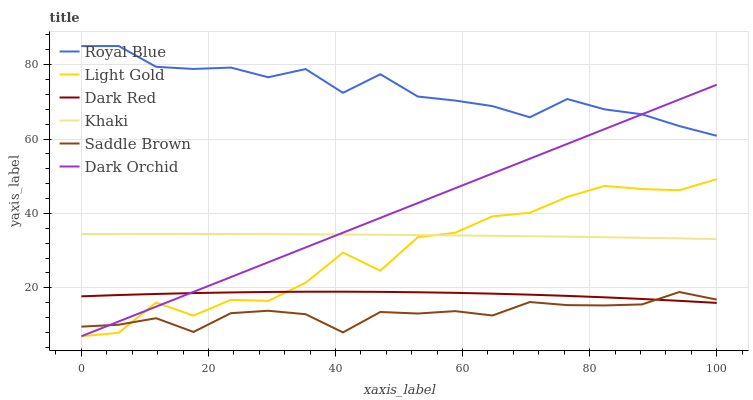Does Saddle Brown have the minimum area under the curve?
Answer yes or no. Yes. Does Royal Blue have the maximum area under the curve?
Answer yes or no. Yes. Does Dark Red have the minimum area under the curve?
Answer yes or no. No. Does Dark Red have the maximum area under the curve?
Answer yes or no. No. Is Dark Orchid the smoothest?
Answer yes or no. Yes. Is Light Gold the roughest?
Answer yes or no. Yes. Is Dark Red the smoothest?
Answer yes or no. No. Is Dark Red the roughest?
Answer yes or no. No. Does Dark Orchid have the lowest value?
Answer yes or no. Yes. Does Dark Red have the lowest value?
Answer yes or no. No. Does Royal Blue have the highest value?
Answer yes or no. Yes. Does Dark Red have the highest value?
Answer yes or no. No. Is Light Gold less than Royal Blue?
Answer yes or no. Yes. Is Khaki greater than Dark Red?
Answer yes or no. Yes. Does Dark Orchid intersect Dark Red?
Answer yes or no. Yes. Is Dark Orchid less than Dark Red?
Answer yes or no. No. Is Dark Orchid greater than Dark Red?
Answer yes or no. No. Does Light Gold intersect Royal Blue?
Answer yes or no. No. 